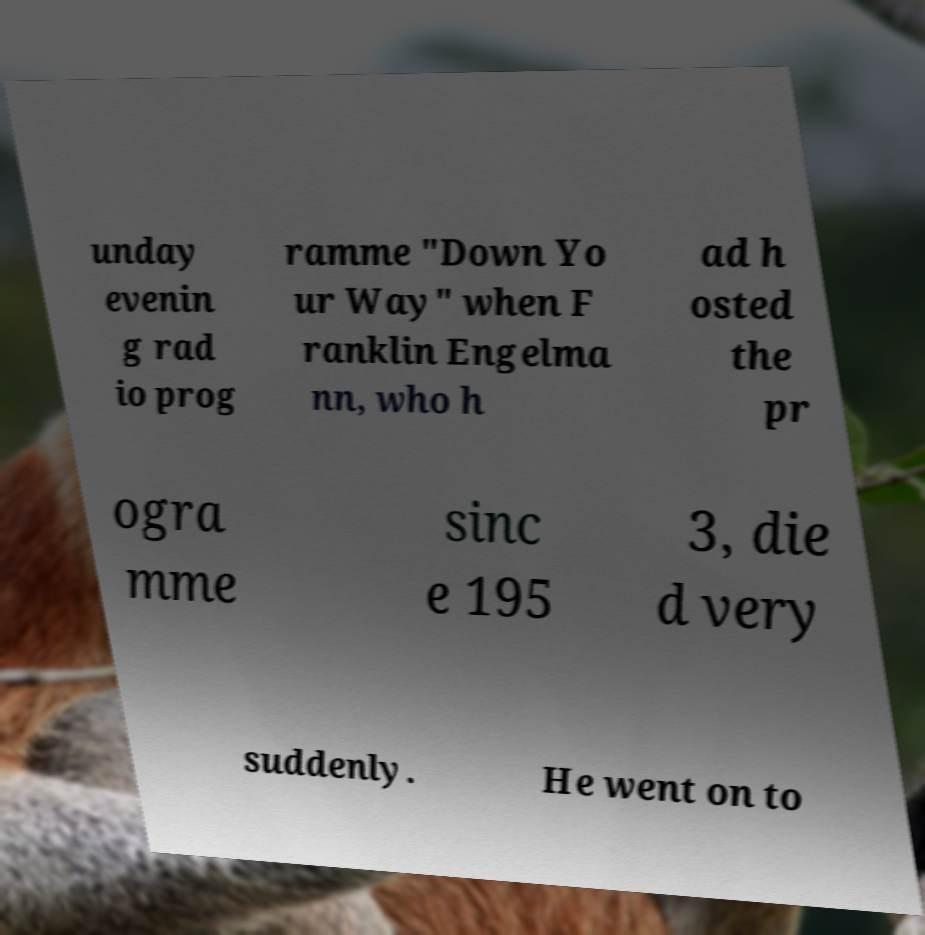Can you accurately transcribe the text from the provided image for me? unday evenin g rad io prog ramme "Down Yo ur Way" when F ranklin Engelma nn, who h ad h osted the pr ogra mme sinc e 195 3, die d very suddenly. He went on to 